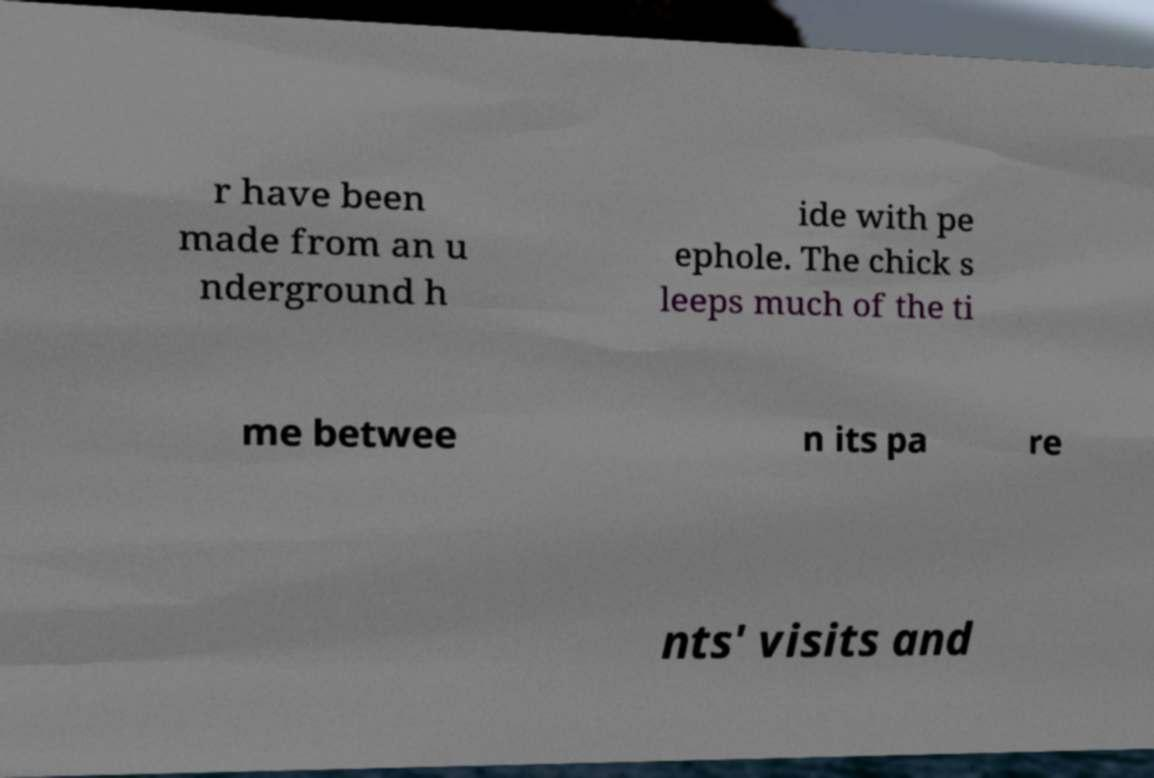For documentation purposes, I need the text within this image transcribed. Could you provide that? r have been made from an u nderground h ide with pe ephole. The chick s leeps much of the ti me betwee n its pa re nts' visits and 